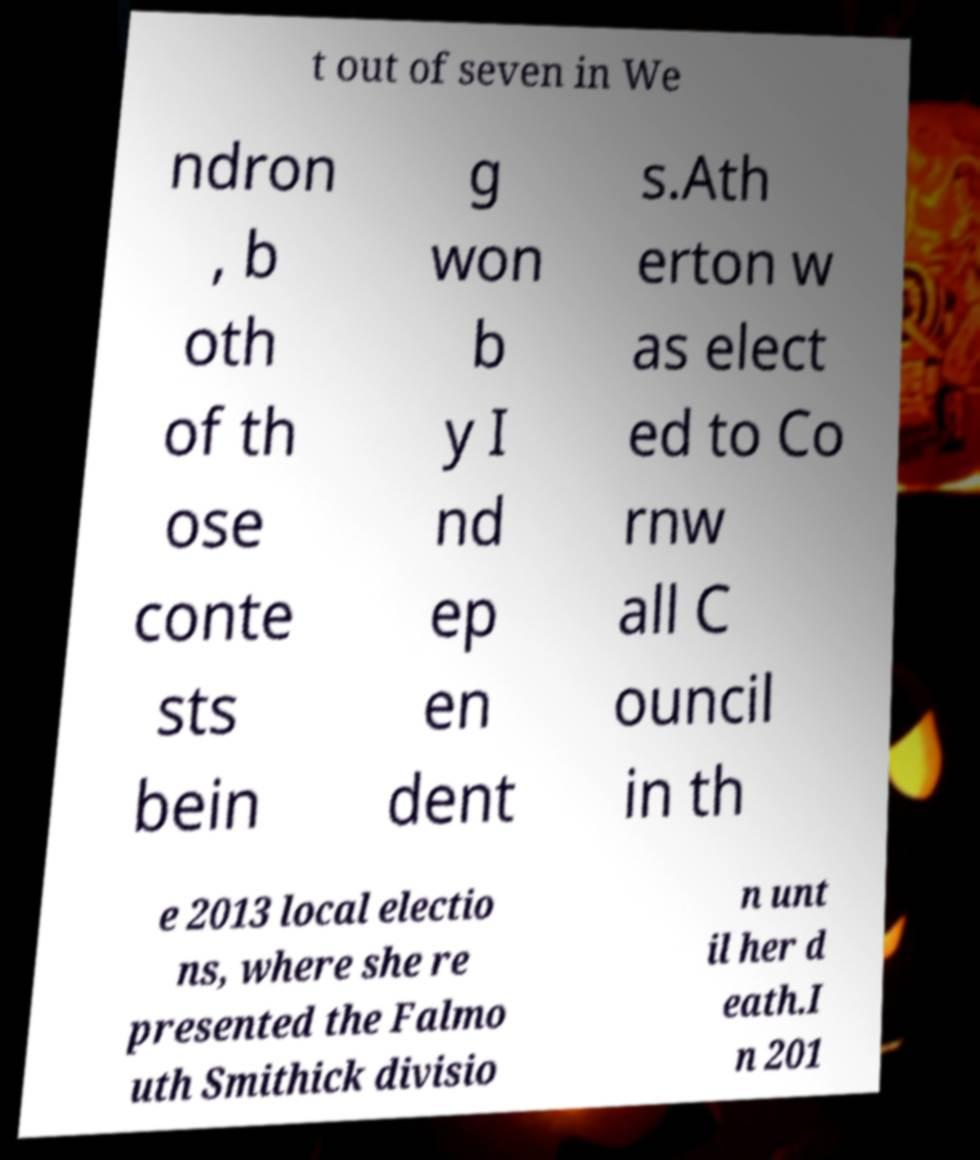For documentation purposes, I need the text within this image transcribed. Could you provide that? t out of seven in We ndron , b oth of th ose conte sts bein g won b y I nd ep en dent s.Ath erton w as elect ed to Co rnw all C ouncil in th e 2013 local electio ns, where she re presented the Falmo uth Smithick divisio n unt il her d eath.I n 201 